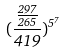Convert formula to latex. <formula><loc_0><loc_0><loc_500><loc_500>( \frac { \frac { 2 9 7 } { 2 6 5 } } { 4 1 9 } ) ^ { 5 ^ { 7 } }</formula> 